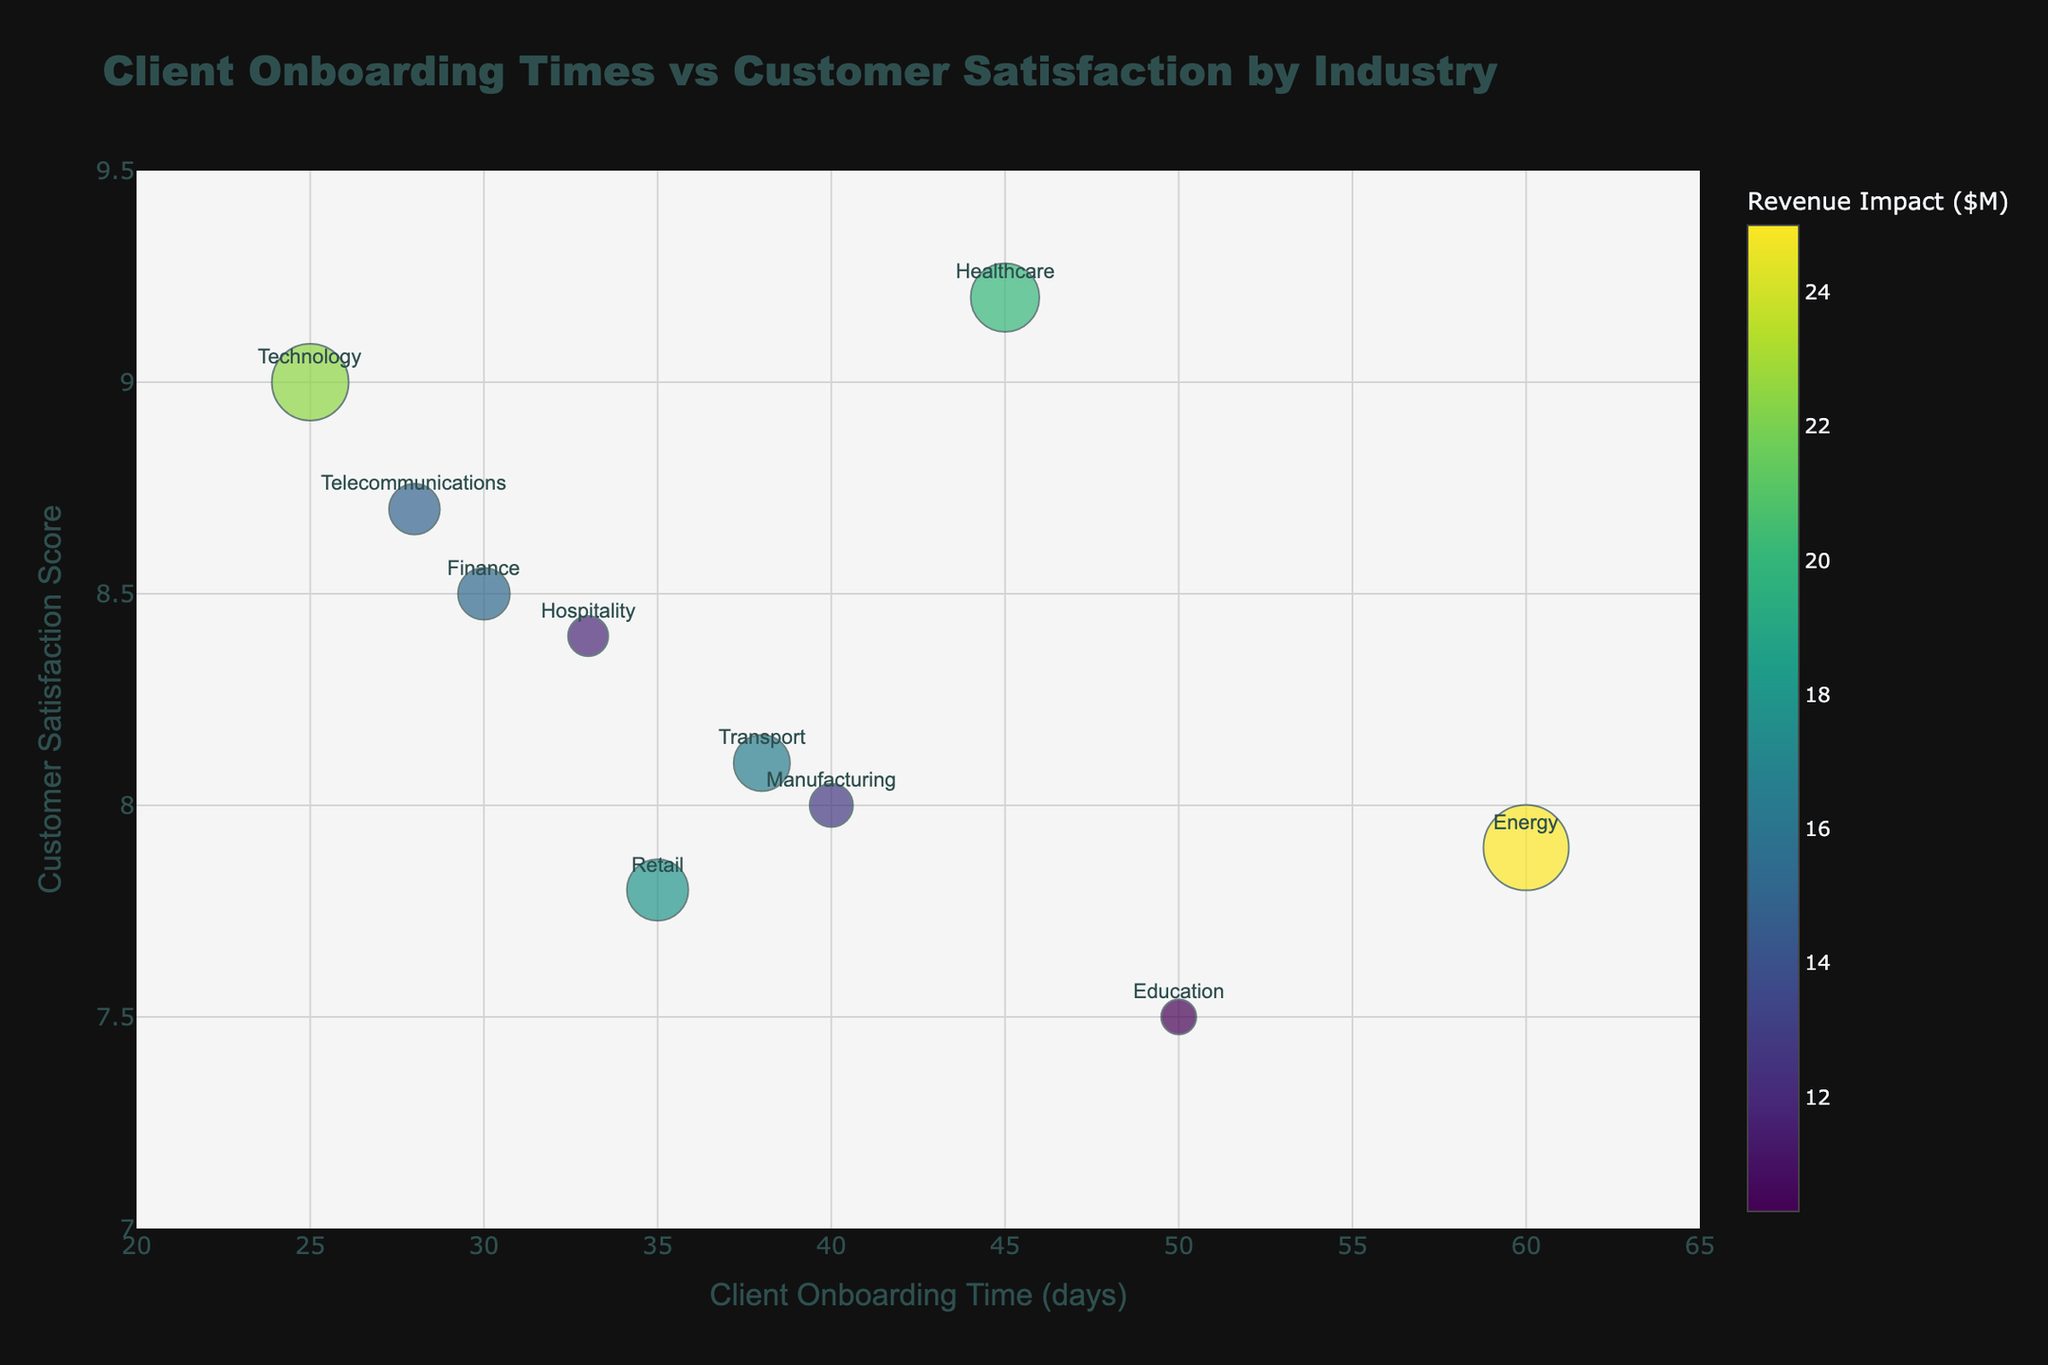What's the average Client Onboarding Time (days) across all industries? To find the average Client Onboarding Time (days), sum all onboarding times and divide by the number of industries. (30 + 45 + 25 + 35 + 40 + 28 + 50 + 60 + 38 + 33) / 10 = 384 / 10 = 38.4 days
Answer: 38.4 days Which industry has the highest Customer Satisfaction Score? To identify the industry with the highest Customer Satisfaction Score, look at the vertical axis (y-axis) and find the highest value. UnitedHealth Group in the Healthcare industry has the highest score of 9.2.
Answer: Healthcare How many industries have a Revenue Impact greater than $15M? Identify industries with marker sizes corresponding to a value greater than $15M. (Finance, Healthcare, Technology, Retail, Energy, Transport). There are 6 industries with Revenue Impact above $15M.
Answer: 6 Which industry has the shortest Client Onboarding Time (days) and what is its Revenue Impact? Identify the smallest value on the horizontal axis (x-axis) representing the shortest onboarding time. Apple in the Technology industry has the shortest onboarding time of 25 days with a Revenue Impact of $22.5M.
Answer: Technology, $22.5M Compare the Customer Satisfaction Scores of the Telecom and Retail industries. Which has a higher score? Find the two industries’ scores on the vertical axis (y-axis). AT&T in Telecom has a score of 8.7, and Walmart in Retail has a score of 7.8. Telecom has the higher score.
Answer: Telecom What's the range of Customer Satisfaction Scores in the chart? Determine the minimum and maximum values on the vertical axis (y-axis). The scores range from 7.5 (Pearson) to 9.2 (UnitedHealth Group).
Answer: 7.5 to 9.2 Which industry has the largest Revenue Impact and what is its Client Onboarding Time? Identify the largest bubble size indicating the highest Revenue Impact. ExxonMobil in the Energy industry has the largest Revenue Impact of $25M and an onboarding time of 60 days.
Answer: Energy, 60 days What's the median Customer Satisfaction Score among the industries? To find the median, list all satisfaction scores and pick the middle value. The scores in ascending order are: 7.5, 7.8, 7.9, 8.0, 8.1, 8.4, 8.5, 8.7, 9.0, 9.2. The middle values are 8.1 and 8.4; thus, the median is (8.1 + 8.4) / 2 = 8.25.
Answer: 8.25 